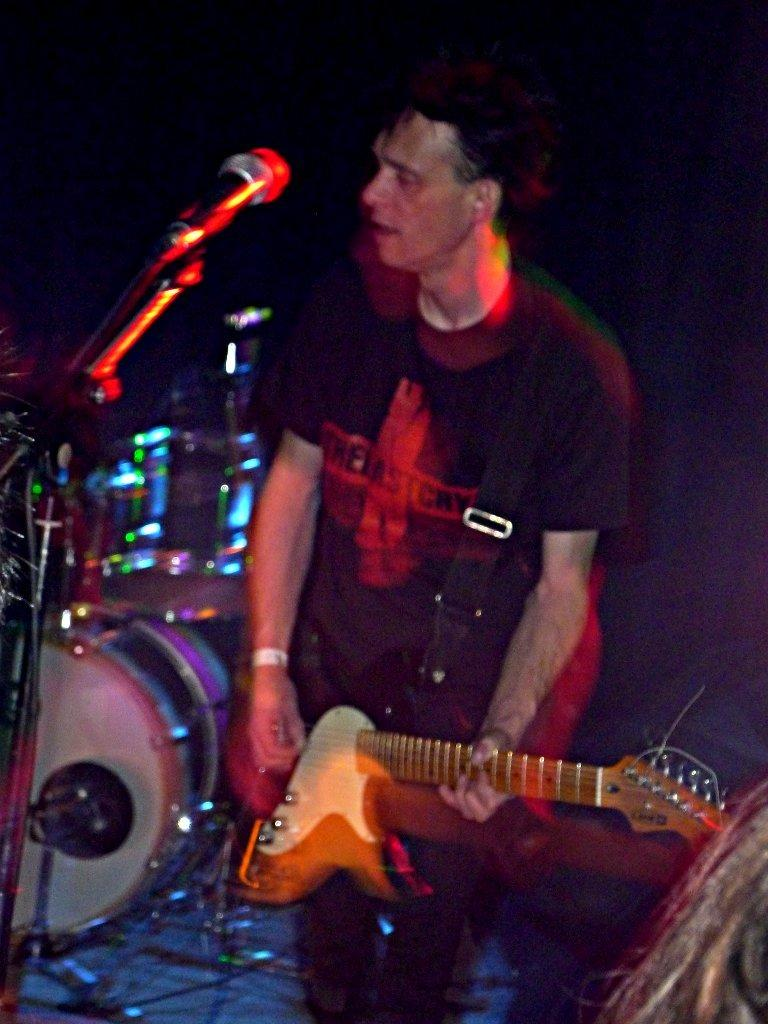What is the person in the image doing? The person is playing a guitar in the image. What other musical instruments can be seen in the image? There are drums in the image. What might the person be using to amplify their voice? There is a microphone in the image. What is present at the bottom of the image? Wires are present at the bottom of the image. What type of shoe is the owner of the drums wearing in the image? There is no shoe or owner of the drums present in the image. 